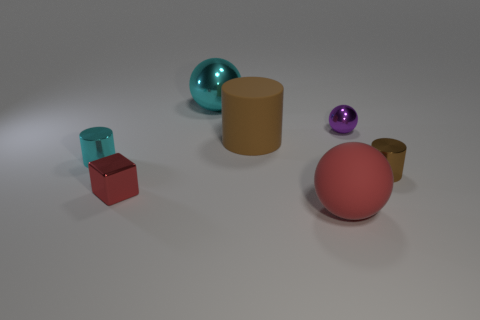How many objects are there in total, and which shape is most common? There are a total of seven objects in the image. The most common shape seems to be the cylindrical form, with two examples present.  Are there any patterns or symmetry in how the objects are arranged? There doesn't appear to be any deliberate pattern or symmetry in the arrangement of the objects. They seem to be placed randomly on the surface. 